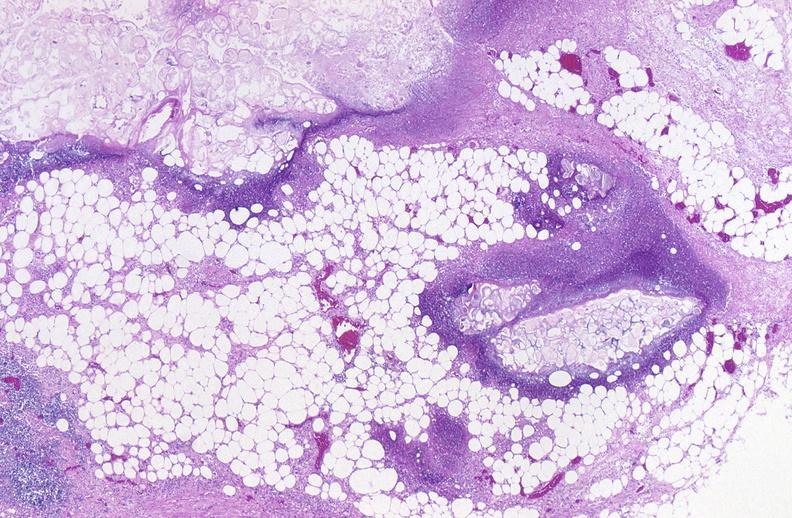does this image show pancreatic fat necrosis?
Answer the question using a single word or phrase. Yes 